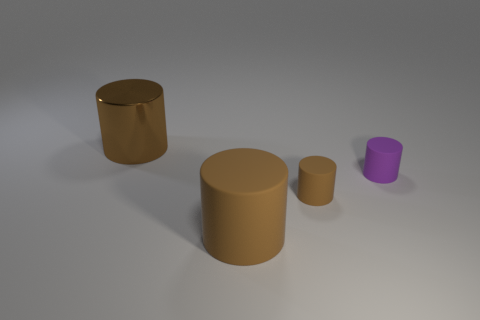There is a metallic cylinder that is the same color as the big rubber thing; what is its size?
Your answer should be compact. Large. There is a tiny rubber thing that is the same color as the large metal thing; what is its shape?
Offer a very short reply. Cylinder. The matte cylinder that is to the right of the small brown cylinder is what color?
Offer a terse response. Purple. Does the thing that is behind the tiny purple object have the same size as the brown matte object right of the large rubber cylinder?
Your answer should be compact. No. Is there a yellow thing that has the same size as the metallic cylinder?
Offer a very short reply. No. There is a brown cylinder to the right of the big matte thing; what number of big things are in front of it?
Ensure brevity in your answer.  1. What is the material of the purple object?
Offer a very short reply. Rubber. There is a small brown matte thing; what number of small brown rubber objects are in front of it?
Keep it short and to the point. 0. Is the color of the metal cylinder the same as the large rubber thing?
Ensure brevity in your answer.  Yes. What number of other small objects are the same color as the metal thing?
Your response must be concise. 1. 